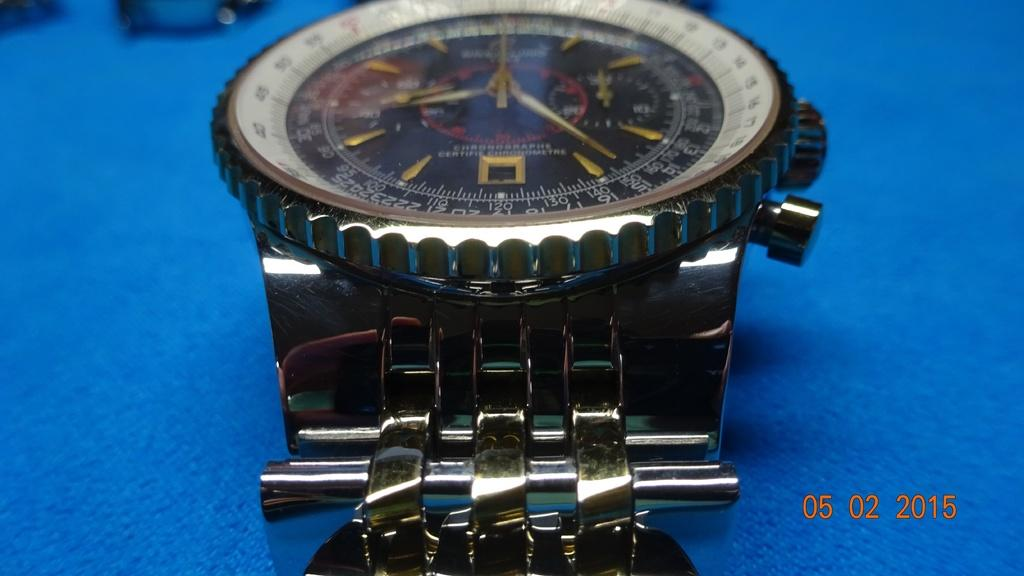<image>
Present a compact description of the photo's key features. A watch sitting on a table that has ChRohosraphe Certific Chrchrometre 